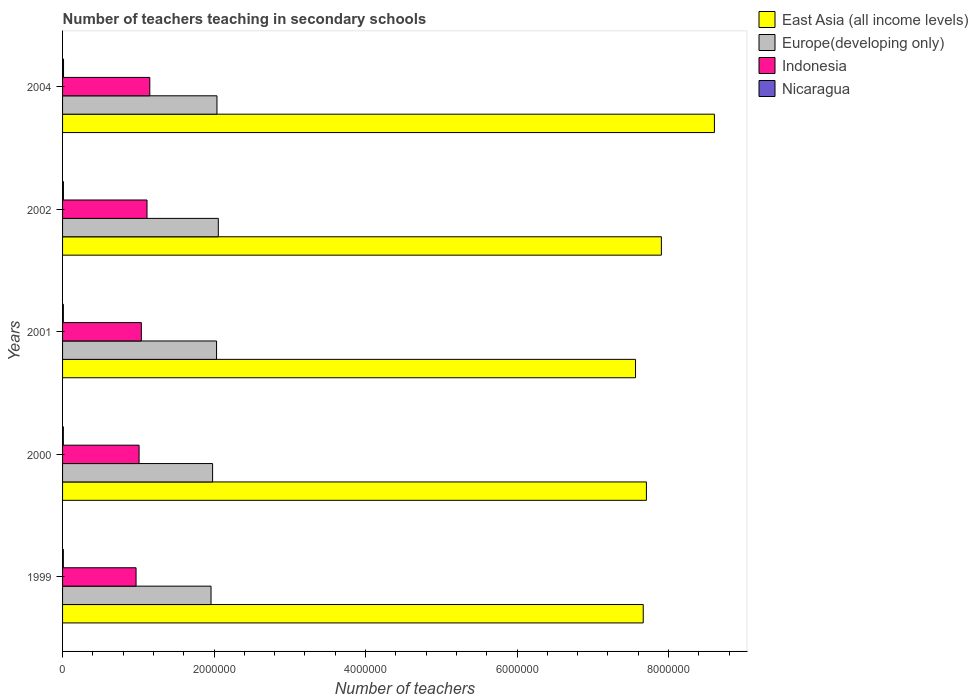How many different coloured bars are there?
Make the answer very short. 4. Are the number of bars per tick equal to the number of legend labels?
Provide a short and direct response. Yes. Are the number of bars on each tick of the Y-axis equal?
Offer a very short reply. Yes. What is the label of the 2nd group of bars from the top?
Offer a terse response. 2002. In how many cases, is the number of bars for a given year not equal to the number of legend labels?
Provide a short and direct response. 0. What is the number of teachers teaching in secondary schools in Indonesia in 2000?
Your answer should be compact. 1.01e+06. Across all years, what is the maximum number of teachers teaching in secondary schools in Nicaragua?
Offer a terse response. 1.28e+04. Across all years, what is the minimum number of teachers teaching in secondary schools in Nicaragua?
Keep it short and to the point. 1.04e+04. In which year was the number of teachers teaching in secondary schools in East Asia (all income levels) minimum?
Give a very brief answer. 2001. What is the total number of teachers teaching in secondary schools in Nicaragua in the graph?
Your answer should be very brief. 5.55e+04. What is the difference between the number of teachers teaching in secondary schools in Nicaragua in 1999 and that in 2001?
Provide a short and direct response. -249. What is the difference between the number of teachers teaching in secondary schools in Indonesia in 2004 and the number of teachers teaching in secondary schools in Europe(developing only) in 2002?
Give a very brief answer. -9.05e+05. What is the average number of teachers teaching in secondary schools in Indonesia per year?
Give a very brief answer. 1.06e+06. In the year 2002, what is the difference between the number of teachers teaching in secondary schools in Indonesia and number of teachers teaching in secondary schools in East Asia (all income levels)?
Provide a succinct answer. -6.79e+06. What is the ratio of the number of teachers teaching in secondary schools in East Asia (all income levels) in 1999 to that in 2004?
Keep it short and to the point. 0.89. Is the number of teachers teaching in secondary schools in East Asia (all income levels) in 2001 less than that in 2002?
Ensure brevity in your answer.  Yes. Is the difference between the number of teachers teaching in secondary schools in Indonesia in 1999 and 2000 greater than the difference between the number of teachers teaching in secondary schools in East Asia (all income levels) in 1999 and 2000?
Provide a short and direct response. Yes. What is the difference between the highest and the second highest number of teachers teaching in secondary schools in Nicaragua?
Your answer should be compact. 1543. What is the difference between the highest and the lowest number of teachers teaching in secondary schools in Indonesia?
Your answer should be very brief. 1.81e+05. What does the 1st bar from the top in 2002 represents?
Your answer should be very brief. Nicaragua. What does the 3rd bar from the bottom in 2000 represents?
Provide a succinct answer. Indonesia. How many bars are there?
Give a very brief answer. 20. What is the difference between two consecutive major ticks on the X-axis?
Your response must be concise. 2.00e+06. How are the legend labels stacked?
Your answer should be compact. Vertical. What is the title of the graph?
Your answer should be very brief. Number of teachers teaching in secondary schools. What is the label or title of the X-axis?
Give a very brief answer. Number of teachers. What is the Number of teachers of East Asia (all income levels) in 1999?
Make the answer very short. 7.67e+06. What is the Number of teachers in Europe(developing only) in 1999?
Make the answer very short. 1.96e+06. What is the Number of teachers of Indonesia in 1999?
Provide a succinct answer. 9.70e+05. What is the Number of teachers in Nicaragua in 1999?
Offer a terse response. 1.04e+04. What is the Number of teachers of East Asia (all income levels) in 2000?
Give a very brief answer. 7.71e+06. What is the Number of teachers of Europe(developing only) in 2000?
Ensure brevity in your answer.  1.98e+06. What is the Number of teachers in Indonesia in 2000?
Keep it short and to the point. 1.01e+06. What is the Number of teachers in Nicaragua in 2000?
Provide a short and direct response. 1.04e+04. What is the Number of teachers of East Asia (all income levels) in 2001?
Ensure brevity in your answer.  7.56e+06. What is the Number of teachers in Europe(developing only) in 2001?
Give a very brief answer. 2.03e+06. What is the Number of teachers of Indonesia in 2001?
Give a very brief answer. 1.04e+06. What is the Number of teachers in Nicaragua in 2001?
Give a very brief answer. 1.06e+04. What is the Number of teachers in East Asia (all income levels) in 2002?
Keep it short and to the point. 7.91e+06. What is the Number of teachers in Europe(developing only) in 2002?
Give a very brief answer. 2.06e+06. What is the Number of teachers of Indonesia in 2002?
Give a very brief answer. 1.11e+06. What is the Number of teachers of Nicaragua in 2002?
Offer a terse response. 1.13e+04. What is the Number of teachers in East Asia (all income levels) in 2004?
Make the answer very short. 8.61e+06. What is the Number of teachers of Europe(developing only) in 2004?
Your answer should be very brief. 2.04e+06. What is the Number of teachers of Indonesia in 2004?
Keep it short and to the point. 1.15e+06. What is the Number of teachers in Nicaragua in 2004?
Give a very brief answer. 1.28e+04. Across all years, what is the maximum Number of teachers in East Asia (all income levels)?
Your response must be concise. 8.61e+06. Across all years, what is the maximum Number of teachers of Europe(developing only)?
Provide a short and direct response. 2.06e+06. Across all years, what is the maximum Number of teachers in Indonesia?
Provide a succinct answer. 1.15e+06. Across all years, what is the maximum Number of teachers of Nicaragua?
Ensure brevity in your answer.  1.28e+04. Across all years, what is the minimum Number of teachers of East Asia (all income levels)?
Offer a very short reply. 7.56e+06. Across all years, what is the minimum Number of teachers of Europe(developing only)?
Make the answer very short. 1.96e+06. Across all years, what is the minimum Number of teachers in Indonesia?
Make the answer very short. 9.70e+05. Across all years, what is the minimum Number of teachers in Nicaragua?
Give a very brief answer. 1.04e+04. What is the total Number of teachers in East Asia (all income levels) in the graph?
Keep it short and to the point. 3.94e+07. What is the total Number of teachers in Europe(developing only) in the graph?
Provide a succinct answer. 1.01e+07. What is the total Number of teachers of Indonesia in the graph?
Offer a terse response. 5.29e+06. What is the total Number of teachers in Nicaragua in the graph?
Make the answer very short. 5.55e+04. What is the difference between the Number of teachers in East Asia (all income levels) in 1999 and that in 2000?
Your answer should be compact. -4.19e+04. What is the difference between the Number of teachers in Europe(developing only) in 1999 and that in 2000?
Offer a very short reply. -2.05e+04. What is the difference between the Number of teachers of Indonesia in 1999 and that in 2000?
Provide a short and direct response. -3.99e+04. What is the difference between the Number of teachers in Nicaragua in 1999 and that in 2000?
Ensure brevity in your answer.  -42. What is the difference between the Number of teachers of East Asia (all income levels) in 1999 and that in 2001?
Provide a short and direct response. 1.02e+05. What is the difference between the Number of teachers of Europe(developing only) in 1999 and that in 2001?
Ensure brevity in your answer.  -7.29e+04. What is the difference between the Number of teachers in Indonesia in 1999 and that in 2001?
Provide a succinct answer. -6.98e+04. What is the difference between the Number of teachers in Nicaragua in 1999 and that in 2001?
Your response must be concise. -249. What is the difference between the Number of teachers in East Asia (all income levels) in 1999 and that in 2002?
Provide a succinct answer. -2.39e+05. What is the difference between the Number of teachers of Europe(developing only) in 1999 and that in 2002?
Your response must be concise. -9.61e+04. What is the difference between the Number of teachers in Indonesia in 1999 and that in 2002?
Provide a succinct answer. -1.45e+05. What is the difference between the Number of teachers of Nicaragua in 1999 and that in 2002?
Keep it short and to the point. -929. What is the difference between the Number of teachers in East Asia (all income levels) in 1999 and that in 2004?
Provide a succinct answer. -9.39e+05. What is the difference between the Number of teachers in Europe(developing only) in 1999 and that in 2004?
Make the answer very short. -7.84e+04. What is the difference between the Number of teachers of Indonesia in 1999 and that in 2004?
Give a very brief answer. -1.81e+05. What is the difference between the Number of teachers of Nicaragua in 1999 and that in 2004?
Offer a terse response. -2472. What is the difference between the Number of teachers in East Asia (all income levels) in 2000 and that in 2001?
Provide a succinct answer. 1.44e+05. What is the difference between the Number of teachers in Europe(developing only) in 2000 and that in 2001?
Offer a terse response. -5.24e+04. What is the difference between the Number of teachers of Indonesia in 2000 and that in 2001?
Keep it short and to the point. -2.99e+04. What is the difference between the Number of teachers of Nicaragua in 2000 and that in 2001?
Your answer should be very brief. -207. What is the difference between the Number of teachers in East Asia (all income levels) in 2000 and that in 2002?
Give a very brief answer. -1.97e+05. What is the difference between the Number of teachers in Europe(developing only) in 2000 and that in 2002?
Your answer should be very brief. -7.56e+04. What is the difference between the Number of teachers of Indonesia in 2000 and that in 2002?
Give a very brief answer. -1.05e+05. What is the difference between the Number of teachers in Nicaragua in 2000 and that in 2002?
Your answer should be very brief. -887. What is the difference between the Number of teachers of East Asia (all income levels) in 2000 and that in 2004?
Give a very brief answer. -8.98e+05. What is the difference between the Number of teachers of Europe(developing only) in 2000 and that in 2004?
Keep it short and to the point. -5.79e+04. What is the difference between the Number of teachers of Indonesia in 2000 and that in 2004?
Your answer should be compact. -1.41e+05. What is the difference between the Number of teachers of Nicaragua in 2000 and that in 2004?
Make the answer very short. -2430. What is the difference between the Number of teachers in East Asia (all income levels) in 2001 and that in 2002?
Ensure brevity in your answer.  -3.41e+05. What is the difference between the Number of teachers in Europe(developing only) in 2001 and that in 2002?
Offer a very short reply. -2.32e+04. What is the difference between the Number of teachers of Indonesia in 2001 and that in 2002?
Your answer should be compact. -7.47e+04. What is the difference between the Number of teachers of Nicaragua in 2001 and that in 2002?
Make the answer very short. -680. What is the difference between the Number of teachers of East Asia (all income levels) in 2001 and that in 2004?
Your answer should be compact. -1.04e+06. What is the difference between the Number of teachers of Europe(developing only) in 2001 and that in 2004?
Offer a terse response. -5475. What is the difference between the Number of teachers of Indonesia in 2001 and that in 2004?
Offer a terse response. -1.12e+05. What is the difference between the Number of teachers of Nicaragua in 2001 and that in 2004?
Ensure brevity in your answer.  -2223. What is the difference between the Number of teachers in East Asia (all income levels) in 2002 and that in 2004?
Your response must be concise. -7.00e+05. What is the difference between the Number of teachers in Europe(developing only) in 2002 and that in 2004?
Give a very brief answer. 1.77e+04. What is the difference between the Number of teachers in Indonesia in 2002 and that in 2004?
Give a very brief answer. -3.68e+04. What is the difference between the Number of teachers in Nicaragua in 2002 and that in 2004?
Keep it short and to the point. -1543. What is the difference between the Number of teachers in East Asia (all income levels) in 1999 and the Number of teachers in Europe(developing only) in 2000?
Give a very brief answer. 5.69e+06. What is the difference between the Number of teachers of East Asia (all income levels) in 1999 and the Number of teachers of Indonesia in 2000?
Keep it short and to the point. 6.66e+06. What is the difference between the Number of teachers in East Asia (all income levels) in 1999 and the Number of teachers in Nicaragua in 2000?
Make the answer very short. 7.66e+06. What is the difference between the Number of teachers of Europe(developing only) in 1999 and the Number of teachers of Indonesia in 2000?
Your answer should be compact. 9.50e+05. What is the difference between the Number of teachers in Europe(developing only) in 1999 and the Number of teachers in Nicaragua in 2000?
Make the answer very short. 1.95e+06. What is the difference between the Number of teachers of Indonesia in 1999 and the Number of teachers of Nicaragua in 2000?
Provide a short and direct response. 9.60e+05. What is the difference between the Number of teachers of East Asia (all income levels) in 1999 and the Number of teachers of Europe(developing only) in 2001?
Offer a very short reply. 5.63e+06. What is the difference between the Number of teachers in East Asia (all income levels) in 1999 and the Number of teachers in Indonesia in 2001?
Ensure brevity in your answer.  6.63e+06. What is the difference between the Number of teachers of East Asia (all income levels) in 1999 and the Number of teachers of Nicaragua in 2001?
Offer a very short reply. 7.66e+06. What is the difference between the Number of teachers of Europe(developing only) in 1999 and the Number of teachers of Indonesia in 2001?
Make the answer very short. 9.20e+05. What is the difference between the Number of teachers in Europe(developing only) in 1999 and the Number of teachers in Nicaragua in 2001?
Keep it short and to the point. 1.95e+06. What is the difference between the Number of teachers of Indonesia in 1999 and the Number of teachers of Nicaragua in 2001?
Your answer should be very brief. 9.60e+05. What is the difference between the Number of teachers in East Asia (all income levels) in 1999 and the Number of teachers in Europe(developing only) in 2002?
Your answer should be compact. 5.61e+06. What is the difference between the Number of teachers of East Asia (all income levels) in 1999 and the Number of teachers of Indonesia in 2002?
Keep it short and to the point. 6.55e+06. What is the difference between the Number of teachers of East Asia (all income levels) in 1999 and the Number of teachers of Nicaragua in 2002?
Your answer should be very brief. 7.65e+06. What is the difference between the Number of teachers of Europe(developing only) in 1999 and the Number of teachers of Indonesia in 2002?
Provide a succinct answer. 8.45e+05. What is the difference between the Number of teachers of Europe(developing only) in 1999 and the Number of teachers of Nicaragua in 2002?
Give a very brief answer. 1.95e+06. What is the difference between the Number of teachers of Indonesia in 1999 and the Number of teachers of Nicaragua in 2002?
Your answer should be compact. 9.59e+05. What is the difference between the Number of teachers in East Asia (all income levels) in 1999 and the Number of teachers in Europe(developing only) in 2004?
Make the answer very short. 5.63e+06. What is the difference between the Number of teachers of East Asia (all income levels) in 1999 and the Number of teachers of Indonesia in 2004?
Keep it short and to the point. 6.51e+06. What is the difference between the Number of teachers in East Asia (all income levels) in 1999 and the Number of teachers in Nicaragua in 2004?
Your answer should be very brief. 7.65e+06. What is the difference between the Number of teachers of Europe(developing only) in 1999 and the Number of teachers of Indonesia in 2004?
Your answer should be very brief. 8.08e+05. What is the difference between the Number of teachers in Europe(developing only) in 1999 and the Number of teachers in Nicaragua in 2004?
Offer a terse response. 1.95e+06. What is the difference between the Number of teachers in Indonesia in 1999 and the Number of teachers in Nicaragua in 2004?
Keep it short and to the point. 9.57e+05. What is the difference between the Number of teachers of East Asia (all income levels) in 2000 and the Number of teachers of Europe(developing only) in 2001?
Make the answer very short. 5.67e+06. What is the difference between the Number of teachers of East Asia (all income levels) in 2000 and the Number of teachers of Indonesia in 2001?
Your response must be concise. 6.67e+06. What is the difference between the Number of teachers of East Asia (all income levels) in 2000 and the Number of teachers of Nicaragua in 2001?
Provide a succinct answer. 7.70e+06. What is the difference between the Number of teachers in Europe(developing only) in 2000 and the Number of teachers in Indonesia in 2001?
Your answer should be very brief. 9.41e+05. What is the difference between the Number of teachers in Europe(developing only) in 2000 and the Number of teachers in Nicaragua in 2001?
Your response must be concise. 1.97e+06. What is the difference between the Number of teachers in Indonesia in 2000 and the Number of teachers in Nicaragua in 2001?
Your answer should be very brief. 1.00e+06. What is the difference between the Number of teachers of East Asia (all income levels) in 2000 and the Number of teachers of Europe(developing only) in 2002?
Your answer should be very brief. 5.65e+06. What is the difference between the Number of teachers of East Asia (all income levels) in 2000 and the Number of teachers of Indonesia in 2002?
Offer a terse response. 6.59e+06. What is the difference between the Number of teachers of East Asia (all income levels) in 2000 and the Number of teachers of Nicaragua in 2002?
Provide a short and direct response. 7.70e+06. What is the difference between the Number of teachers of Europe(developing only) in 2000 and the Number of teachers of Indonesia in 2002?
Offer a very short reply. 8.66e+05. What is the difference between the Number of teachers of Europe(developing only) in 2000 and the Number of teachers of Nicaragua in 2002?
Your answer should be very brief. 1.97e+06. What is the difference between the Number of teachers in Indonesia in 2000 and the Number of teachers in Nicaragua in 2002?
Offer a terse response. 9.99e+05. What is the difference between the Number of teachers of East Asia (all income levels) in 2000 and the Number of teachers of Europe(developing only) in 2004?
Ensure brevity in your answer.  5.67e+06. What is the difference between the Number of teachers of East Asia (all income levels) in 2000 and the Number of teachers of Indonesia in 2004?
Your answer should be very brief. 6.56e+06. What is the difference between the Number of teachers in East Asia (all income levels) in 2000 and the Number of teachers in Nicaragua in 2004?
Make the answer very short. 7.70e+06. What is the difference between the Number of teachers of Europe(developing only) in 2000 and the Number of teachers of Indonesia in 2004?
Make the answer very short. 8.29e+05. What is the difference between the Number of teachers of Europe(developing only) in 2000 and the Number of teachers of Nicaragua in 2004?
Your answer should be compact. 1.97e+06. What is the difference between the Number of teachers in Indonesia in 2000 and the Number of teachers in Nicaragua in 2004?
Make the answer very short. 9.97e+05. What is the difference between the Number of teachers of East Asia (all income levels) in 2001 and the Number of teachers of Europe(developing only) in 2002?
Your response must be concise. 5.51e+06. What is the difference between the Number of teachers in East Asia (all income levels) in 2001 and the Number of teachers in Indonesia in 2002?
Provide a succinct answer. 6.45e+06. What is the difference between the Number of teachers in East Asia (all income levels) in 2001 and the Number of teachers in Nicaragua in 2002?
Provide a short and direct response. 7.55e+06. What is the difference between the Number of teachers in Europe(developing only) in 2001 and the Number of teachers in Indonesia in 2002?
Offer a terse response. 9.18e+05. What is the difference between the Number of teachers of Europe(developing only) in 2001 and the Number of teachers of Nicaragua in 2002?
Make the answer very short. 2.02e+06. What is the difference between the Number of teachers in Indonesia in 2001 and the Number of teachers in Nicaragua in 2002?
Offer a terse response. 1.03e+06. What is the difference between the Number of teachers in East Asia (all income levels) in 2001 and the Number of teachers in Europe(developing only) in 2004?
Your answer should be compact. 5.53e+06. What is the difference between the Number of teachers in East Asia (all income levels) in 2001 and the Number of teachers in Indonesia in 2004?
Keep it short and to the point. 6.41e+06. What is the difference between the Number of teachers in East Asia (all income levels) in 2001 and the Number of teachers in Nicaragua in 2004?
Offer a terse response. 7.55e+06. What is the difference between the Number of teachers of Europe(developing only) in 2001 and the Number of teachers of Indonesia in 2004?
Keep it short and to the point. 8.81e+05. What is the difference between the Number of teachers in Europe(developing only) in 2001 and the Number of teachers in Nicaragua in 2004?
Offer a very short reply. 2.02e+06. What is the difference between the Number of teachers in Indonesia in 2001 and the Number of teachers in Nicaragua in 2004?
Ensure brevity in your answer.  1.03e+06. What is the difference between the Number of teachers of East Asia (all income levels) in 2002 and the Number of teachers of Europe(developing only) in 2004?
Offer a very short reply. 5.87e+06. What is the difference between the Number of teachers in East Asia (all income levels) in 2002 and the Number of teachers in Indonesia in 2004?
Your response must be concise. 6.75e+06. What is the difference between the Number of teachers of East Asia (all income levels) in 2002 and the Number of teachers of Nicaragua in 2004?
Provide a succinct answer. 7.89e+06. What is the difference between the Number of teachers of Europe(developing only) in 2002 and the Number of teachers of Indonesia in 2004?
Your answer should be very brief. 9.05e+05. What is the difference between the Number of teachers of Europe(developing only) in 2002 and the Number of teachers of Nicaragua in 2004?
Ensure brevity in your answer.  2.04e+06. What is the difference between the Number of teachers of Indonesia in 2002 and the Number of teachers of Nicaragua in 2004?
Give a very brief answer. 1.10e+06. What is the average Number of teachers in East Asia (all income levels) per year?
Your answer should be very brief. 7.89e+06. What is the average Number of teachers in Europe(developing only) per year?
Offer a terse response. 2.01e+06. What is the average Number of teachers in Indonesia per year?
Make the answer very short. 1.06e+06. What is the average Number of teachers of Nicaragua per year?
Your answer should be compact. 1.11e+04. In the year 1999, what is the difference between the Number of teachers of East Asia (all income levels) and Number of teachers of Europe(developing only)?
Your response must be concise. 5.71e+06. In the year 1999, what is the difference between the Number of teachers in East Asia (all income levels) and Number of teachers in Indonesia?
Your answer should be very brief. 6.70e+06. In the year 1999, what is the difference between the Number of teachers in East Asia (all income levels) and Number of teachers in Nicaragua?
Offer a very short reply. 7.66e+06. In the year 1999, what is the difference between the Number of teachers in Europe(developing only) and Number of teachers in Indonesia?
Give a very brief answer. 9.90e+05. In the year 1999, what is the difference between the Number of teachers of Europe(developing only) and Number of teachers of Nicaragua?
Make the answer very short. 1.95e+06. In the year 1999, what is the difference between the Number of teachers in Indonesia and Number of teachers in Nicaragua?
Offer a very short reply. 9.60e+05. In the year 2000, what is the difference between the Number of teachers in East Asia (all income levels) and Number of teachers in Europe(developing only)?
Provide a succinct answer. 5.73e+06. In the year 2000, what is the difference between the Number of teachers in East Asia (all income levels) and Number of teachers in Indonesia?
Make the answer very short. 6.70e+06. In the year 2000, what is the difference between the Number of teachers of East Asia (all income levels) and Number of teachers of Nicaragua?
Make the answer very short. 7.70e+06. In the year 2000, what is the difference between the Number of teachers in Europe(developing only) and Number of teachers in Indonesia?
Give a very brief answer. 9.70e+05. In the year 2000, what is the difference between the Number of teachers in Europe(developing only) and Number of teachers in Nicaragua?
Offer a very short reply. 1.97e+06. In the year 2000, what is the difference between the Number of teachers of Indonesia and Number of teachers of Nicaragua?
Offer a terse response. 1.00e+06. In the year 2001, what is the difference between the Number of teachers in East Asia (all income levels) and Number of teachers in Europe(developing only)?
Provide a short and direct response. 5.53e+06. In the year 2001, what is the difference between the Number of teachers in East Asia (all income levels) and Number of teachers in Indonesia?
Your answer should be compact. 6.52e+06. In the year 2001, what is the difference between the Number of teachers of East Asia (all income levels) and Number of teachers of Nicaragua?
Your answer should be compact. 7.55e+06. In the year 2001, what is the difference between the Number of teachers in Europe(developing only) and Number of teachers in Indonesia?
Make the answer very short. 9.93e+05. In the year 2001, what is the difference between the Number of teachers of Europe(developing only) and Number of teachers of Nicaragua?
Keep it short and to the point. 2.02e+06. In the year 2001, what is the difference between the Number of teachers of Indonesia and Number of teachers of Nicaragua?
Give a very brief answer. 1.03e+06. In the year 2002, what is the difference between the Number of teachers of East Asia (all income levels) and Number of teachers of Europe(developing only)?
Your answer should be very brief. 5.85e+06. In the year 2002, what is the difference between the Number of teachers of East Asia (all income levels) and Number of teachers of Indonesia?
Your response must be concise. 6.79e+06. In the year 2002, what is the difference between the Number of teachers of East Asia (all income levels) and Number of teachers of Nicaragua?
Your response must be concise. 7.89e+06. In the year 2002, what is the difference between the Number of teachers of Europe(developing only) and Number of teachers of Indonesia?
Offer a very short reply. 9.41e+05. In the year 2002, what is the difference between the Number of teachers of Europe(developing only) and Number of teachers of Nicaragua?
Your response must be concise. 2.04e+06. In the year 2002, what is the difference between the Number of teachers in Indonesia and Number of teachers in Nicaragua?
Your response must be concise. 1.10e+06. In the year 2004, what is the difference between the Number of teachers of East Asia (all income levels) and Number of teachers of Europe(developing only)?
Your answer should be compact. 6.57e+06. In the year 2004, what is the difference between the Number of teachers in East Asia (all income levels) and Number of teachers in Indonesia?
Keep it short and to the point. 7.45e+06. In the year 2004, what is the difference between the Number of teachers in East Asia (all income levels) and Number of teachers in Nicaragua?
Give a very brief answer. 8.59e+06. In the year 2004, what is the difference between the Number of teachers of Europe(developing only) and Number of teachers of Indonesia?
Your answer should be compact. 8.87e+05. In the year 2004, what is the difference between the Number of teachers in Europe(developing only) and Number of teachers in Nicaragua?
Keep it short and to the point. 2.03e+06. In the year 2004, what is the difference between the Number of teachers of Indonesia and Number of teachers of Nicaragua?
Make the answer very short. 1.14e+06. What is the ratio of the Number of teachers in Europe(developing only) in 1999 to that in 2000?
Keep it short and to the point. 0.99. What is the ratio of the Number of teachers in Indonesia in 1999 to that in 2000?
Provide a succinct answer. 0.96. What is the ratio of the Number of teachers in Nicaragua in 1999 to that in 2000?
Offer a terse response. 1. What is the ratio of the Number of teachers in East Asia (all income levels) in 1999 to that in 2001?
Offer a very short reply. 1.01. What is the ratio of the Number of teachers in Europe(developing only) in 1999 to that in 2001?
Keep it short and to the point. 0.96. What is the ratio of the Number of teachers in Indonesia in 1999 to that in 2001?
Offer a terse response. 0.93. What is the ratio of the Number of teachers of Nicaragua in 1999 to that in 2001?
Your response must be concise. 0.98. What is the ratio of the Number of teachers in East Asia (all income levels) in 1999 to that in 2002?
Your answer should be compact. 0.97. What is the ratio of the Number of teachers in Europe(developing only) in 1999 to that in 2002?
Provide a short and direct response. 0.95. What is the ratio of the Number of teachers of Indonesia in 1999 to that in 2002?
Your answer should be very brief. 0.87. What is the ratio of the Number of teachers of Nicaragua in 1999 to that in 2002?
Make the answer very short. 0.92. What is the ratio of the Number of teachers in East Asia (all income levels) in 1999 to that in 2004?
Keep it short and to the point. 0.89. What is the ratio of the Number of teachers of Europe(developing only) in 1999 to that in 2004?
Keep it short and to the point. 0.96. What is the ratio of the Number of teachers in Indonesia in 1999 to that in 2004?
Make the answer very short. 0.84. What is the ratio of the Number of teachers in Nicaragua in 1999 to that in 2004?
Provide a short and direct response. 0.81. What is the ratio of the Number of teachers in East Asia (all income levels) in 2000 to that in 2001?
Offer a very short reply. 1.02. What is the ratio of the Number of teachers in Europe(developing only) in 2000 to that in 2001?
Ensure brevity in your answer.  0.97. What is the ratio of the Number of teachers in Indonesia in 2000 to that in 2001?
Your answer should be very brief. 0.97. What is the ratio of the Number of teachers in Nicaragua in 2000 to that in 2001?
Your answer should be compact. 0.98. What is the ratio of the Number of teachers in Europe(developing only) in 2000 to that in 2002?
Offer a terse response. 0.96. What is the ratio of the Number of teachers of Indonesia in 2000 to that in 2002?
Your response must be concise. 0.91. What is the ratio of the Number of teachers in Nicaragua in 2000 to that in 2002?
Your answer should be very brief. 0.92. What is the ratio of the Number of teachers in East Asia (all income levels) in 2000 to that in 2004?
Offer a terse response. 0.9. What is the ratio of the Number of teachers of Europe(developing only) in 2000 to that in 2004?
Your response must be concise. 0.97. What is the ratio of the Number of teachers in Indonesia in 2000 to that in 2004?
Provide a succinct answer. 0.88. What is the ratio of the Number of teachers of Nicaragua in 2000 to that in 2004?
Offer a terse response. 0.81. What is the ratio of the Number of teachers of East Asia (all income levels) in 2001 to that in 2002?
Ensure brevity in your answer.  0.96. What is the ratio of the Number of teachers in Europe(developing only) in 2001 to that in 2002?
Give a very brief answer. 0.99. What is the ratio of the Number of teachers of Indonesia in 2001 to that in 2002?
Offer a terse response. 0.93. What is the ratio of the Number of teachers in Nicaragua in 2001 to that in 2002?
Ensure brevity in your answer.  0.94. What is the ratio of the Number of teachers of East Asia (all income levels) in 2001 to that in 2004?
Your answer should be very brief. 0.88. What is the ratio of the Number of teachers in Indonesia in 2001 to that in 2004?
Your answer should be compact. 0.9. What is the ratio of the Number of teachers in Nicaragua in 2001 to that in 2004?
Provide a short and direct response. 0.83. What is the ratio of the Number of teachers in East Asia (all income levels) in 2002 to that in 2004?
Give a very brief answer. 0.92. What is the ratio of the Number of teachers of Europe(developing only) in 2002 to that in 2004?
Offer a terse response. 1.01. What is the ratio of the Number of teachers in Indonesia in 2002 to that in 2004?
Provide a succinct answer. 0.97. What is the ratio of the Number of teachers in Nicaragua in 2002 to that in 2004?
Keep it short and to the point. 0.88. What is the difference between the highest and the second highest Number of teachers in East Asia (all income levels)?
Offer a terse response. 7.00e+05. What is the difference between the highest and the second highest Number of teachers of Europe(developing only)?
Your answer should be compact. 1.77e+04. What is the difference between the highest and the second highest Number of teachers of Indonesia?
Ensure brevity in your answer.  3.68e+04. What is the difference between the highest and the second highest Number of teachers in Nicaragua?
Keep it short and to the point. 1543. What is the difference between the highest and the lowest Number of teachers in East Asia (all income levels)?
Give a very brief answer. 1.04e+06. What is the difference between the highest and the lowest Number of teachers of Europe(developing only)?
Ensure brevity in your answer.  9.61e+04. What is the difference between the highest and the lowest Number of teachers of Indonesia?
Your answer should be very brief. 1.81e+05. What is the difference between the highest and the lowest Number of teachers in Nicaragua?
Make the answer very short. 2472. 